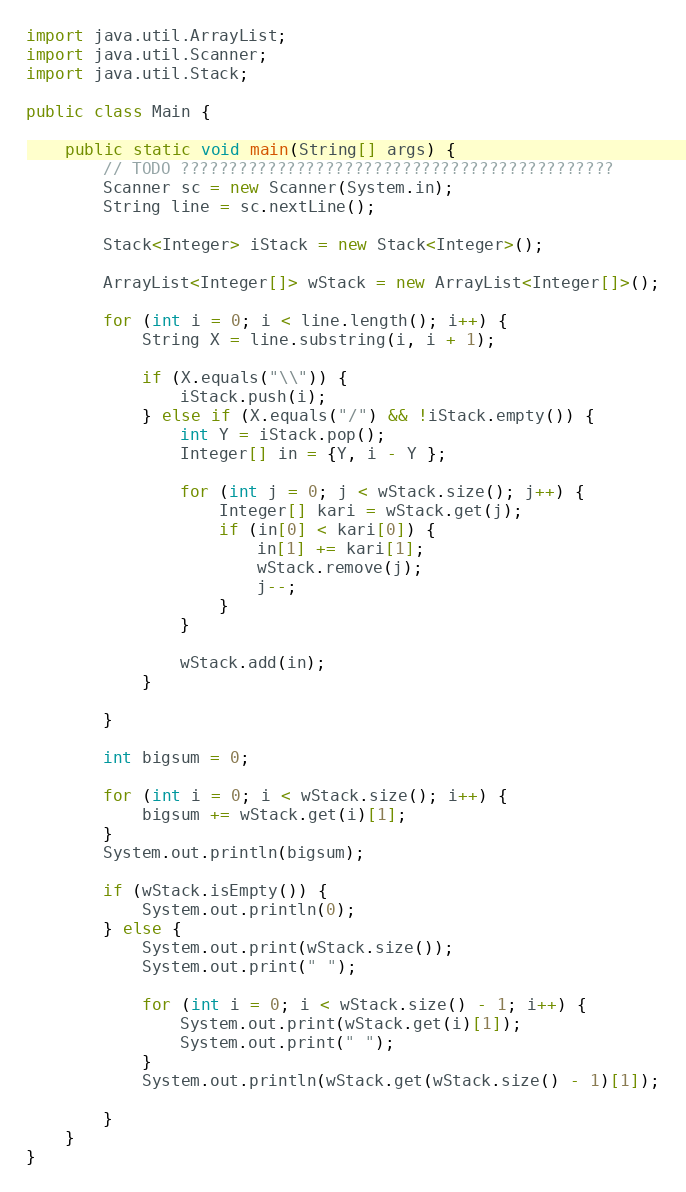Convert code to text. <code><loc_0><loc_0><loc_500><loc_500><_Java_>import java.util.ArrayList;
import java.util.Scanner;
import java.util.Stack;

public class Main {

	public static void main(String[] args) {
		// TODO ?????????????????????????????????????????????
		Scanner sc = new Scanner(System.in);
		String line = sc.nextLine();

		Stack<Integer> iStack = new Stack<Integer>();

		ArrayList<Integer[]> wStack = new ArrayList<Integer[]>();

		for (int i = 0; i < line.length(); i++) {
			String X = line.substring(i, i + 1);

			if (X.equals("\\")) {
				iStack.push(i);
			} else if (X.equals("/") && !iStack.empty()) {
				int Y = iStack.pop();
				Integer[] in = {Y, i - Y };
				
				for (int j = 0; j < wStack.size(); j++) {
					Integer[] kari = wStack.get(j);
					if (in[0] < kari[0]) {
						in[1] += kari[1];
						wStack.remove(j);
						j--;
					}
				}
				
				wStack.add(in);
			}

		}
		
		int bigsum = 0;

		for (int i = 0; i < wStack.size(); i++) {
			bigsum += wStack.get(i)[1];
		}
		System.out.println(bigsum);
		
		if (wStack.isEmpty()) {
			System.out.println(0);
		} else {
			System.out.print(wStack.size());
			System.out.print(" ");
			
			for (int i = 0; i < wStack.size() - 1; i++) {
				System.out.print(wStack.get(i)[1]);
				System.out.print(" ");
			}
			System.out.println(wStack.get(wStack.size() - 1)[1]);

		}
	}
}</code> 